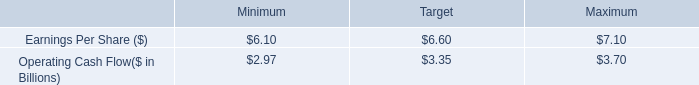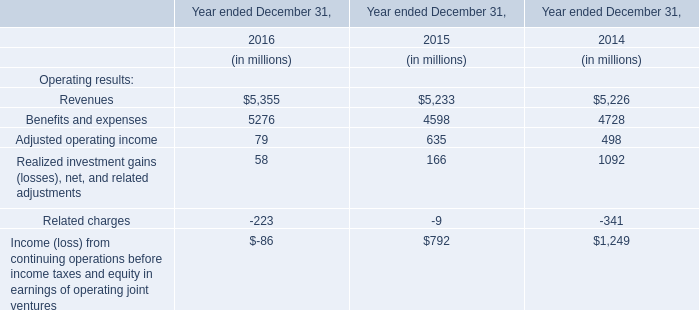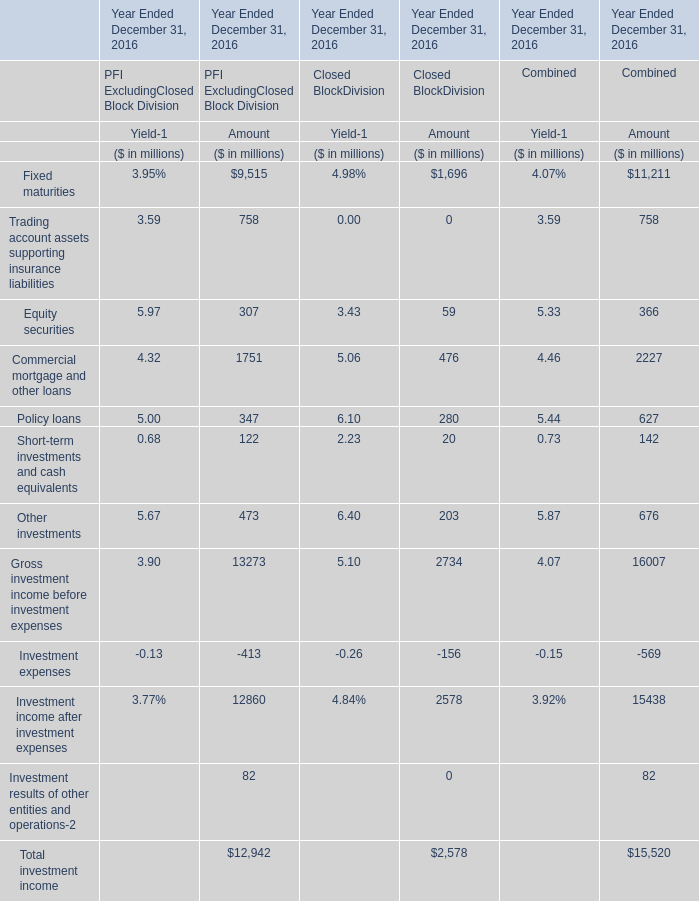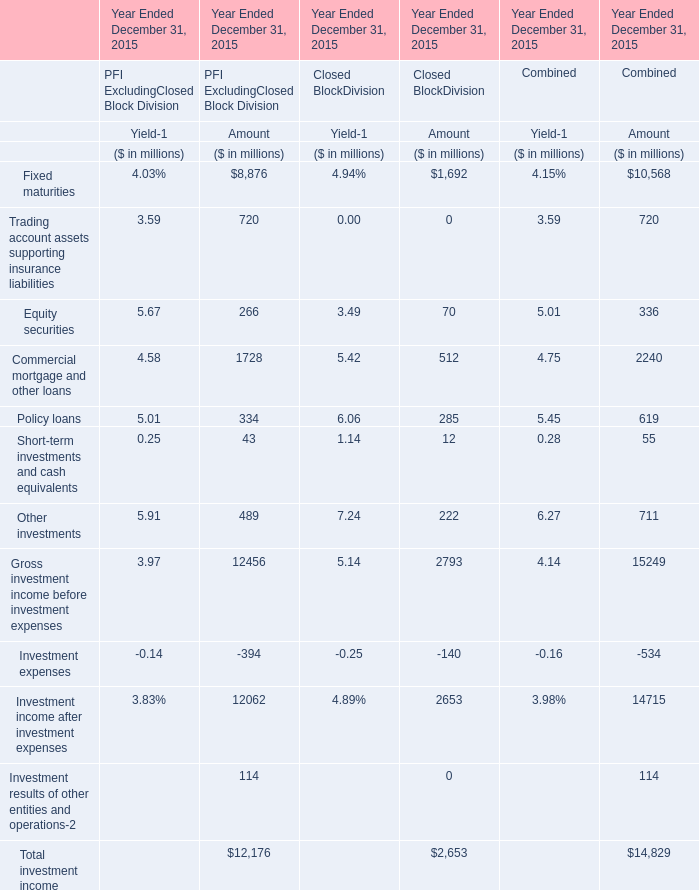Does the value of rading account assets supporting insurance liabilities in Yield-1 greater than that in Amount for PFI ExcludingClosed Block Division 
Answer: no. 